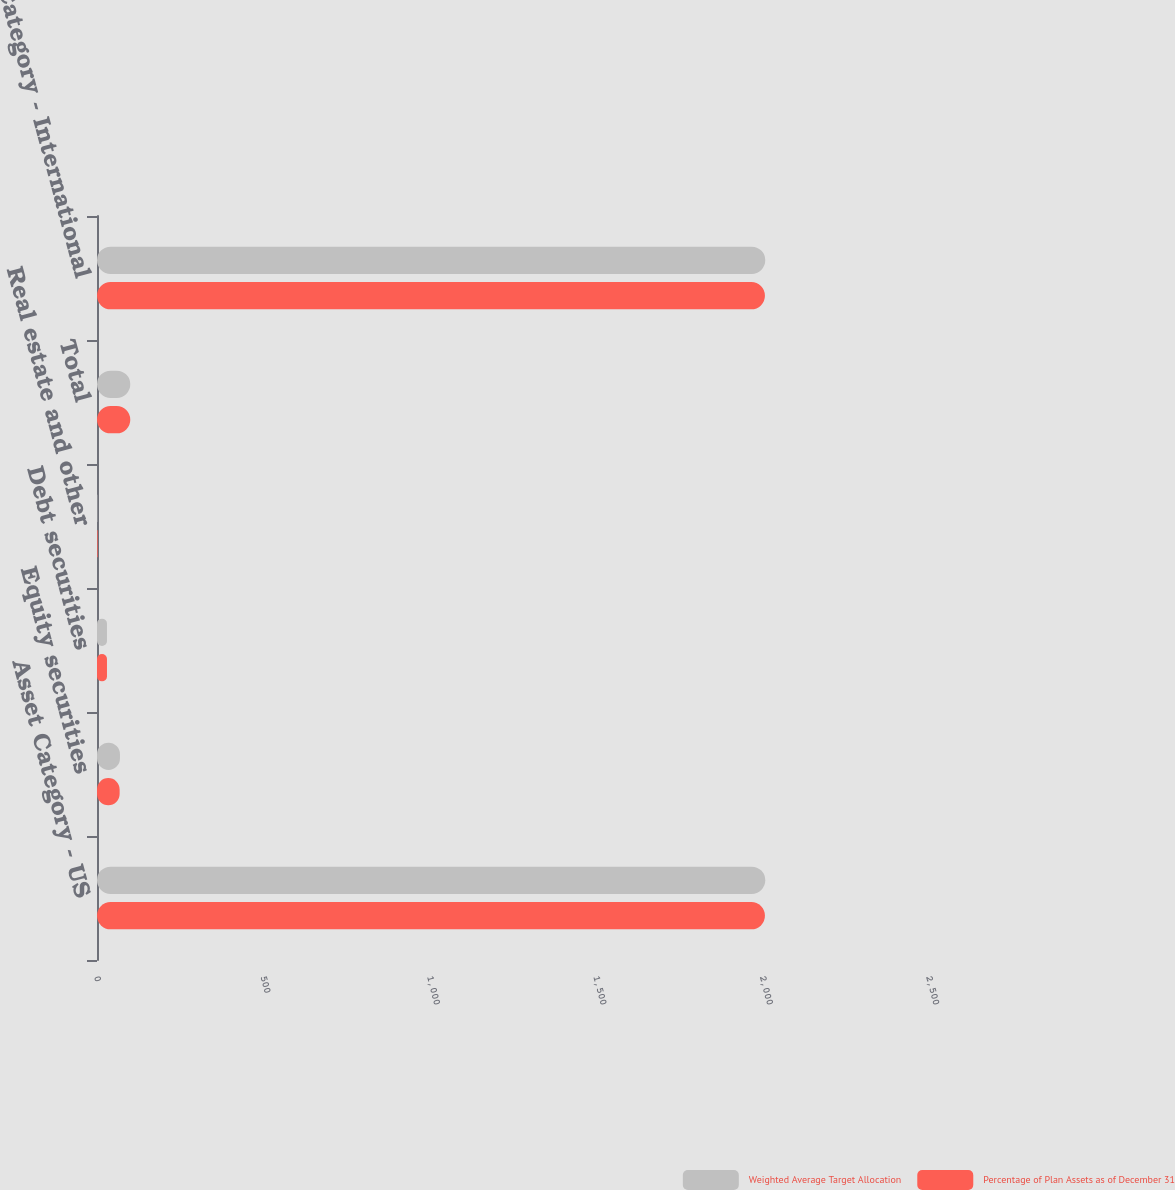<chart> <loc_0><loc_0><loc_500><loc_500><stacked_bar_chart><ecel><fcel>Asset Category - US<fcel>Equity securities<fcel>Debt securities<fcel>Real estate and other<fcel>Total<fcel>Asset Category - International<nl><fcel>Weighted Average Target Allocation<fcel>2008<fcel>69<fcel>30<fcel>1<fcel>100<fcel>2008<nl><fcel>Percentage of Plan Assets as of December 31<fcel>2007<fcel>68<fcel>30<fcel>2<fcel>100<fcel>2007<nl></chart> 